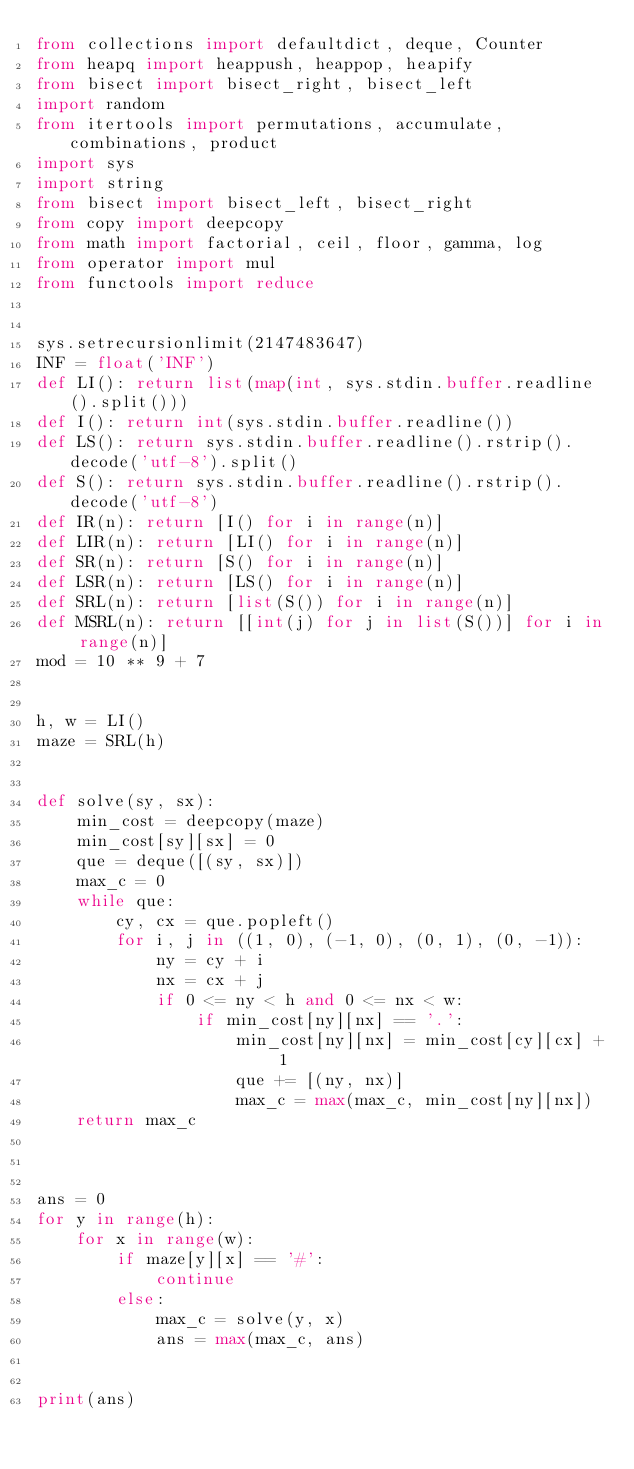<code> <loc_0><loc_0><loc_500><loc_500><_Python_>from collections import defaultdict, deque, Counter
from heapq import heappush, heappop, heapify
from bisect import bisect_right, bisect_left
import random
from itertools import permutations, accumulate, combinations, product
import sys
import string
from bisect import bisect_left, bisect_right
from copy import deepcopy
from math import factorial, ceil, floor, gamma, log
from operator import mul
from functools import reduce


sys.setrecursionlimit(2147483647)
INF = float('INF')
def LI(): return list(map(int, sys.stdin.buffer.readline().split()))
def I(): return int(sys.stdin.buffer.readline())
def LS(): return sys.stdin.buffer.readline().rstrip().decode('utf-8').split()
def S(): return sys.stdin.buffer.readline().rstrip().decode('utf-8')
def IR(n): return [I() for i in range(n)]
def LIR(n): return [LI() for i in range(n)]
def SR(n): return [S() for i in range(n)]
def LSR(n): return [LS() for i in range(n)]
def SRL(n): return [list(S()) for i in range(n)]
def MSRL(n): return [[int(j) for j in list(S())] for i in range(n)]
mod = 10 ** 9 + 7


h, w = LI()
maze = SRL(h)


def solve(sy, sx):
    min_cost = deepcopy(maze)
    min_cost[sy][sx] = 0
    que = deque([(sy, sx)])
    max_c = 0
    while que:
        cy, cx = que.popleft()
        for i, j in ((1, 0), (-1, 0), (0, 1), (0, -1)):
            ny = cy + i
            nx = cx + j
            if 0 <= ny < h and 0 <= nx < w:
                if min_cost[ny][nx] == '.':
                    min_cost[ny][nx] = min_cost[cy][cx] + 1
                    que += [(ny, nx)]
                    max_c = max(max_c, min_cost[ny][nx])
    return max_c



ans = 0
for y in range(h):
    for x in range(w):
        if maze[y][x] == '#':
            continue
        else:
            max_c = solve(y, x)
            ans = max(max_c, ans)


print(ans)</code> 